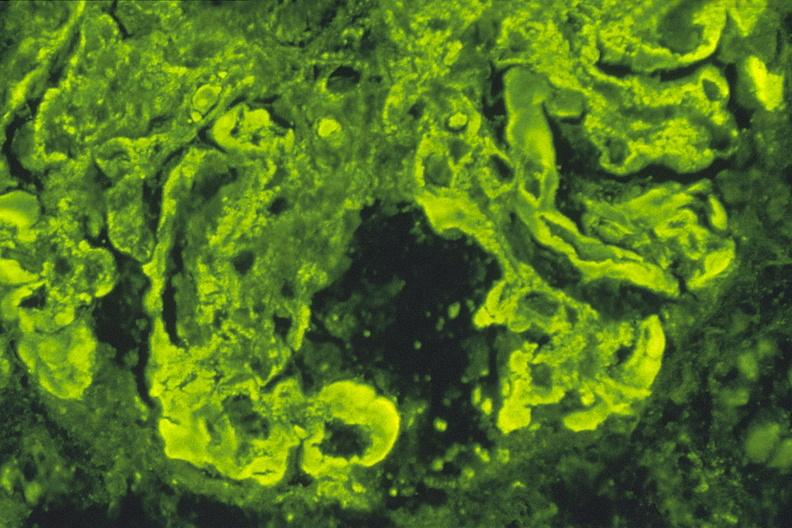s urinary present?
Answer the question using a single word or phrase. Yes 